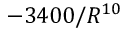Convert formula to latex. <formula><loc_0><loc_0><loc_500><loc_500>- 3 4 0 0 / R ^ { 1 0 }</formula> 